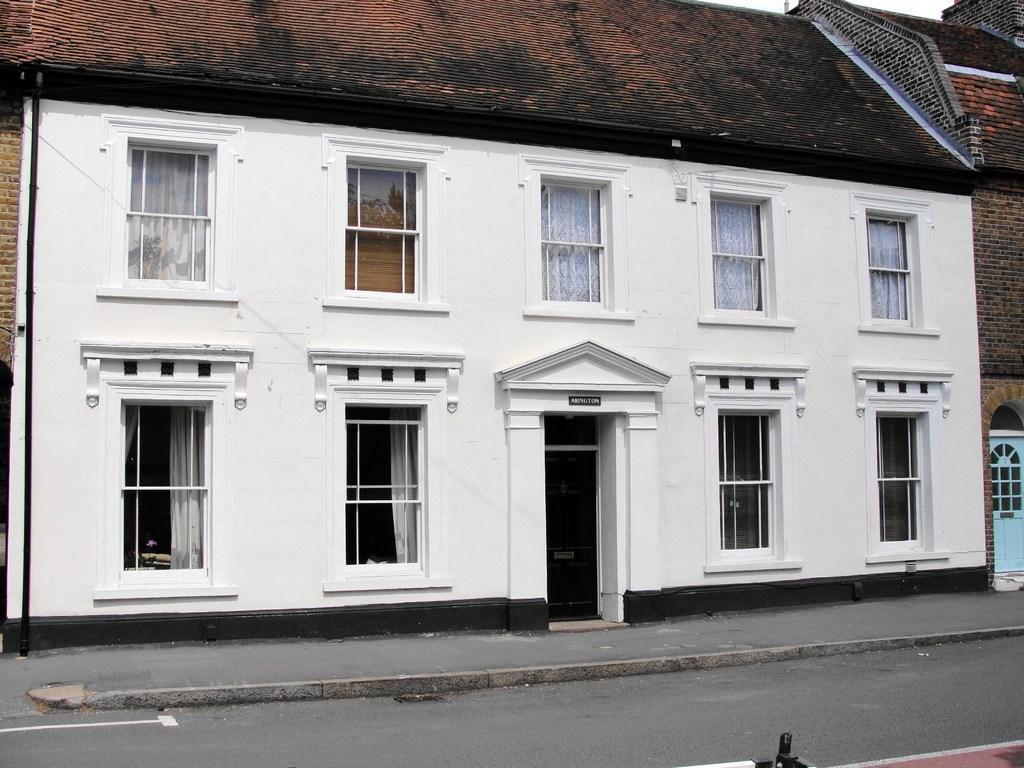In one or two sentences, can you explain what this image depicts? In the center of the image we can see a door, board. In the background of the image we can see the houses, windows, roof. At the bottom of the image we can see the road. At the top of the image we can see the sky. 